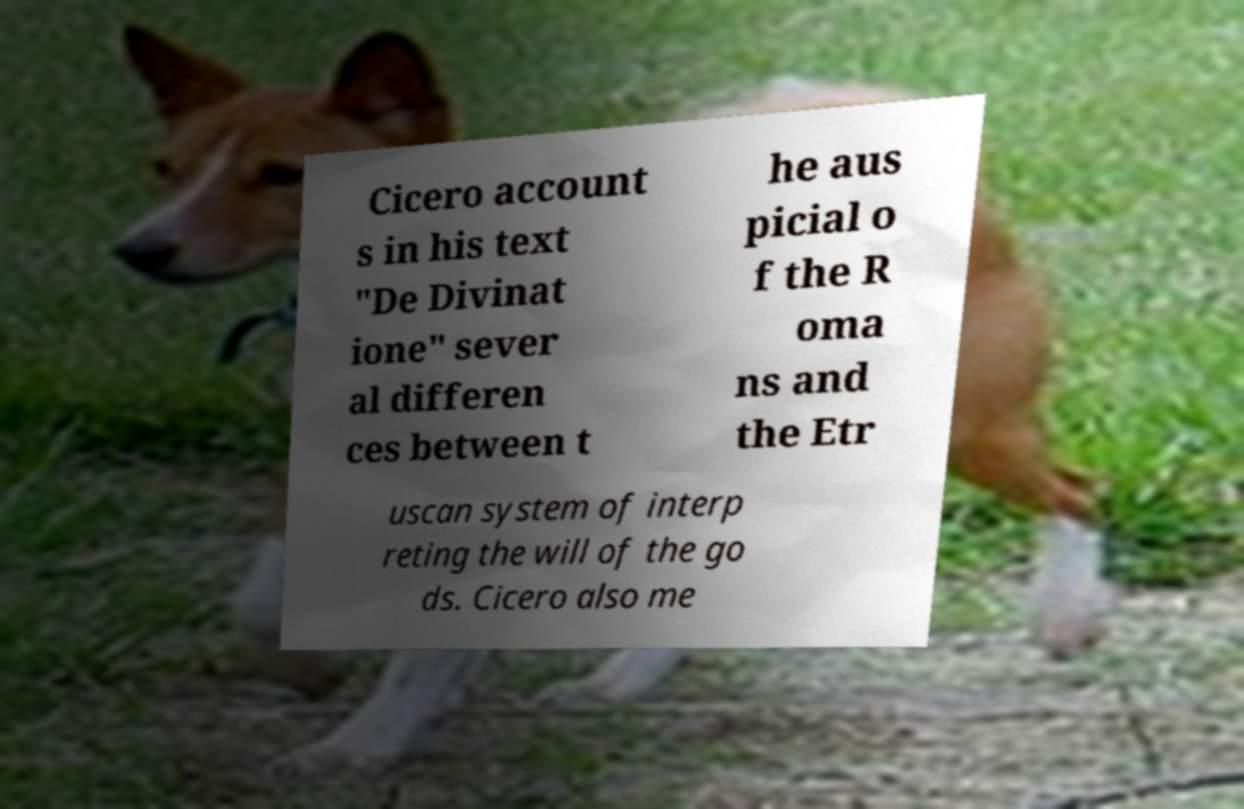For documentation purposes, I need the text within this image transcribed. Could you provide that? Cicero account s in his text "De Divinat ione" sever al differen ces between t he aus picial o f the R oma ns and the Etr uscan system of interp reting the will of the go ds. Cicero also me 